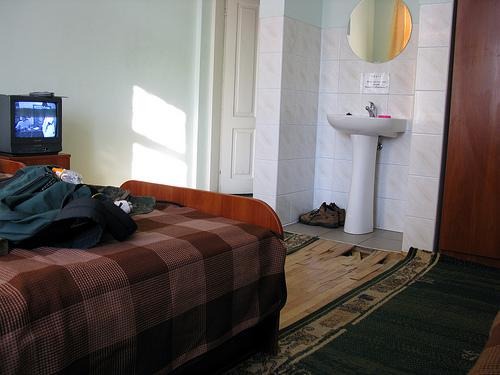Question: what room is this?
Choices:
A. Kitchen.
B. Living room.
C. Bathroom.
D. Bedroom.
Answer with the letter. Answer: D Question: where is the mirror?
Choices:
A. Above the sink.
B. Behind couch.
C. Behind door.
D. Above door.
Answer with the letter. Answer: A Question: how many beds are there?
Choices:
A. Two.
B. One.
C. Three.
D. Four.
Answer with the letter. Answer: B Question: where is the television?
Choices:
A. Above the fireplace.
B. On the table.
C. In the cupboard.
D. Left wall.
Answer with the letter. Answer: D Question: what size is the television?
Choices:
A. Small.
B. Large.
C. Huge.
D. Medium.
Answer with the letter. Answer: A 